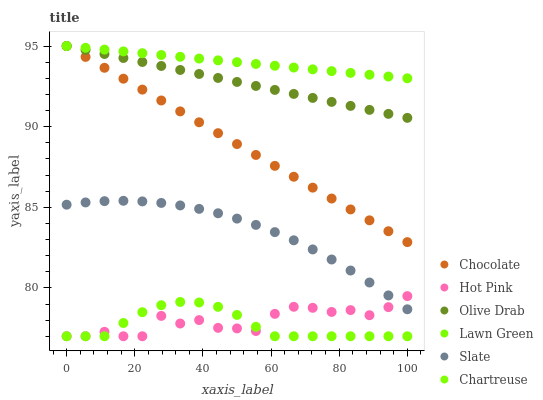Does Chartreuse have the minimum area under the curve?
Answer yes or no. Yes. Does Lawn Green have the maximum area under the curve?
Answer yes or no. Yes. Does Slate have the minimum area under the curve?
Answer yes or no. No. Does Slate have the maximum area under the curve?
Answer yes or no. No. Is Lawn Green the smoothest?
Answer yes or no. Yes. Is Hot Pink the roughest?
Answer yes or no. Yes. Is Slate the smoothest?
Answer yes or no. No. Is Slate the roughest?
Answer yes or no. No. Does Hot Pink have the lowest value?
Answer yes or no. Yes. Does Slate have the lowest value?
Answer yes or no. No. Does Olive Drab have the highest value?
Answer yes or no. Yes. Does Slate have the highest value?
Answer yes or no. No. Is Chartreuse less than Chocolate?
Answer yes or no. Yes. Is Chocolate greater than Slate?
Answer yes or no. Yes. Does Chocolate intersect Lawn Green?
Answer yes or no. Yes. Is Chocolate less than Lawn Green?
Answer yes or no. No. Is Chocolate greater than Lawn Green?
Answer yes or no. No. Does Chartreuse intersect Chocolate?
Answer yes or no. No. 